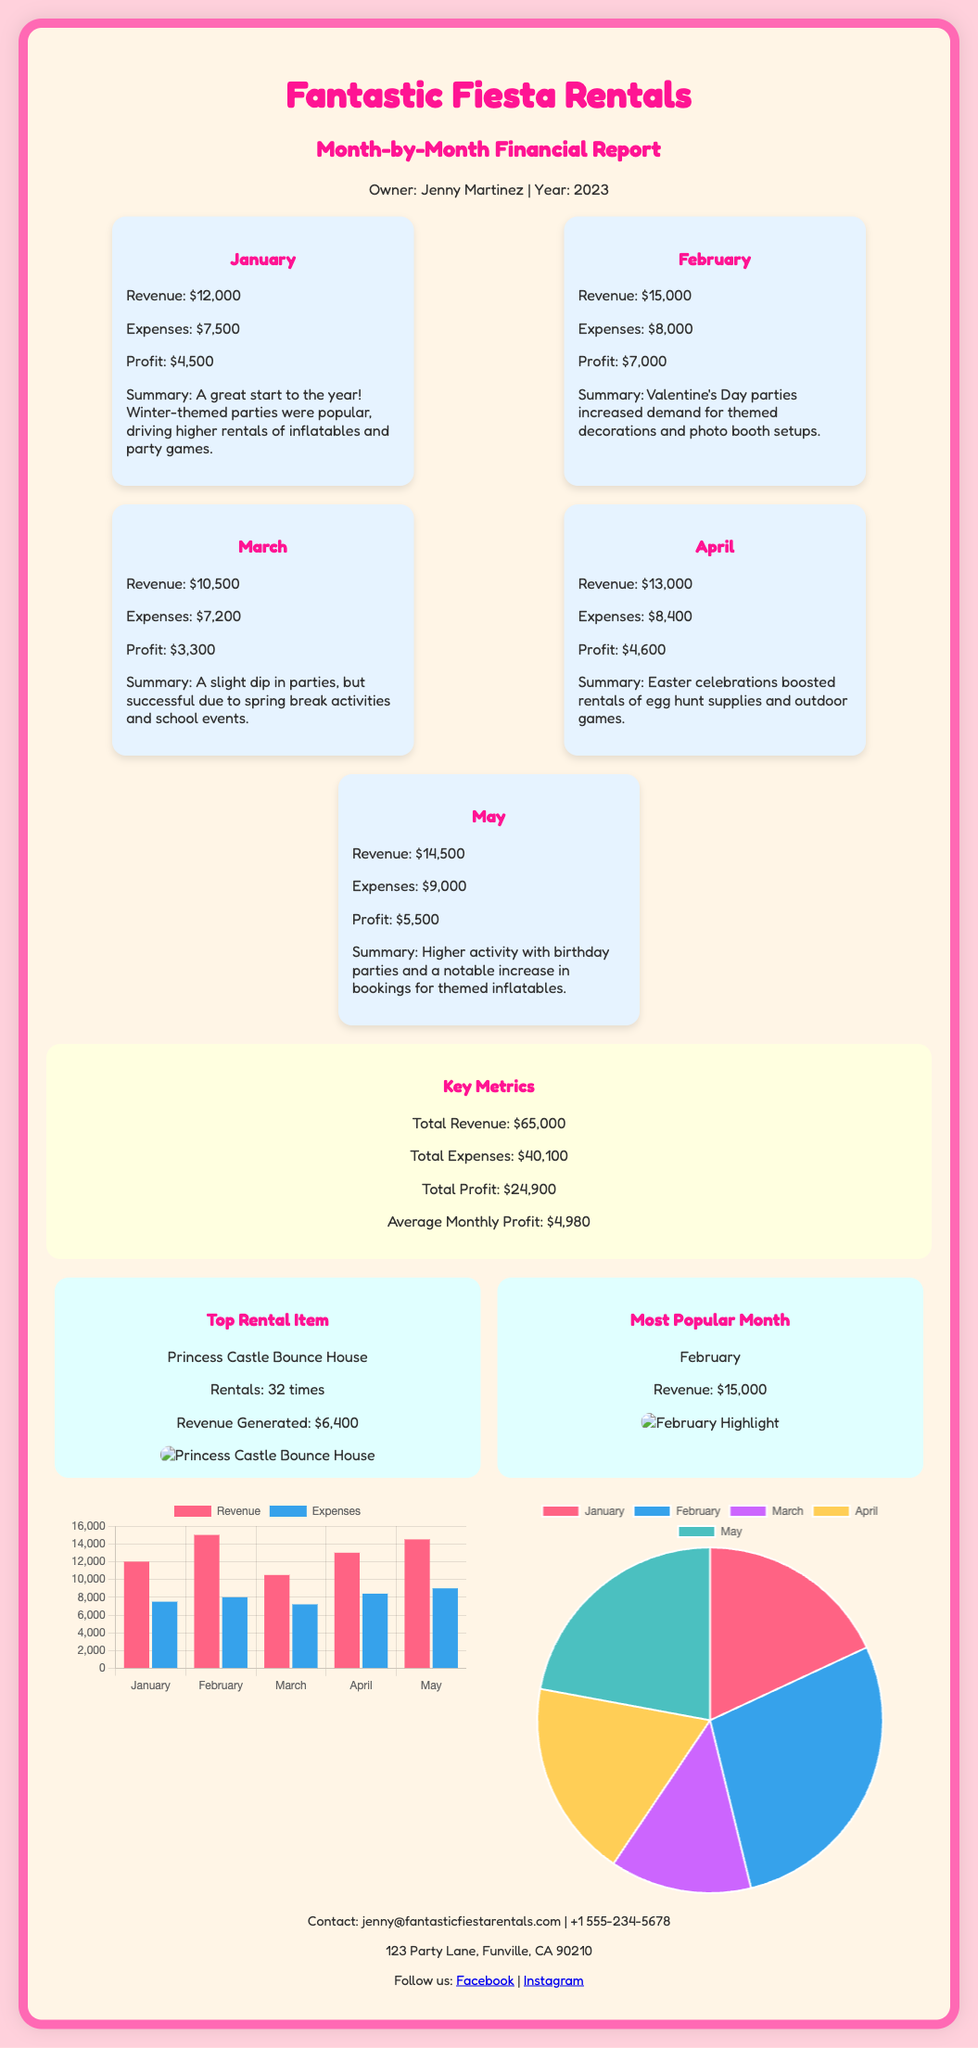What is the total revenue? The total revenue is calculated by summing up the revenue for each month from January to May: $12,000 + $15,000 + $10,500 + $13,000 + $14,500 = $65,000.
Answer: $65,000 What was the profit in February? The profit for February is listed in the document as $7,000.
Answer: $7,000 Which month had the highest expenses? The month with the highest expenses is February, with total expenses of $8,000.
Answer: February What is the summary for March? The summary for March indicates there was a slight dip in parties but successful activities due to spring break and school events.
Answer: A slight dip in parties, successful due to spring break activities and school events What is the most popular rental item? The most popular rental item for the business is the Princess Castle Bounce House.
Answer: Princess Castle Bounce House How much profit was made in May? The profit made in May is stated as $5,500.
Answer: $5,500 What is the average monthly profit? The average monthly profit is calculated from the total profit divided by the number of months, which is $24,900 / 5 = $4,980.
Answer: $4,980 Which month had the highest revenue? The month with the highest revenue is February, totaling $15,000.
Answer: February What is the total profit? The total profit is the sum of the profits for each month: $4,500 + $7,000 + $3,300 + $4,600 + $5,500 = $24,900.
Answer: $24,900 